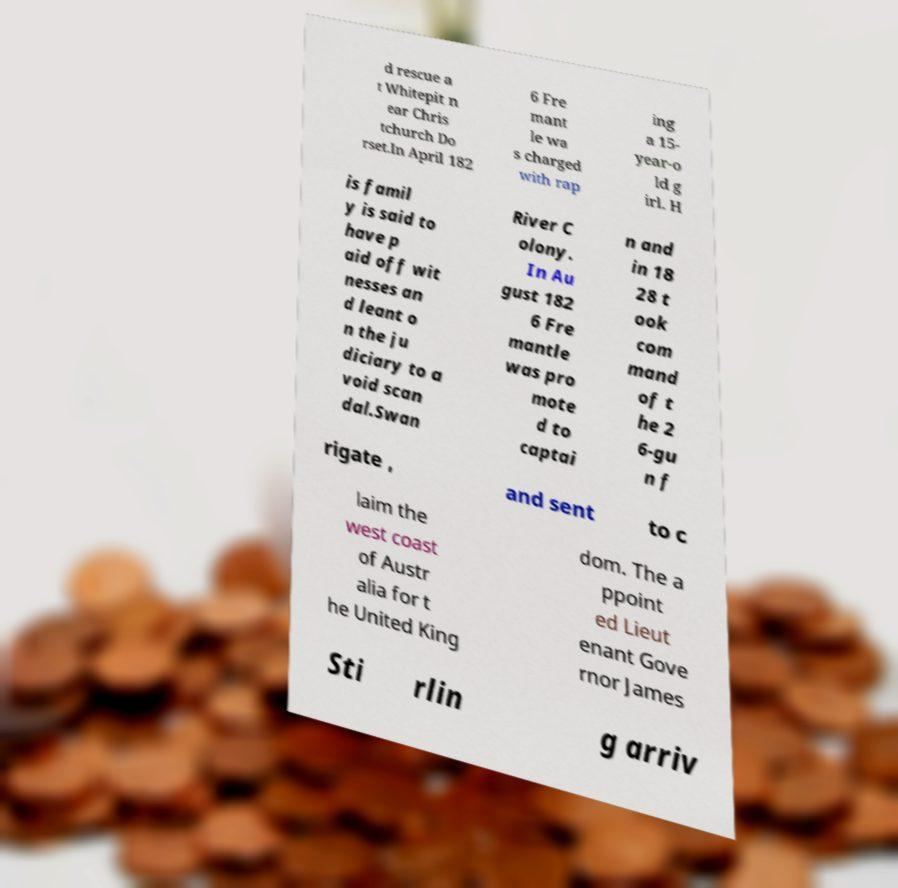Can you read and provide the text displayed in the image?This photo seems to have some interesting text. Can you extract and type it out for me? d rescue a t Whitepit n ear Chris tchurch Do rset.In April 182 6 Fre mant le wa s charged with rap ing a 15- year-o ld g irl. H is famil y is said to have p aid off wit nesses an d leant o n the ju diciary to a void scan dal.Swan River C olony. In Au gust 182 6 Fre mantle was pro mote d to captai n and in 18 28 t ook com mand of t he 2 6-gu n f rigate , and sent to c laim the west coast of Austr alia for t he United King dom. The a ppoint ed Lieut enant Gove rnor James Sti rlin g arriv 